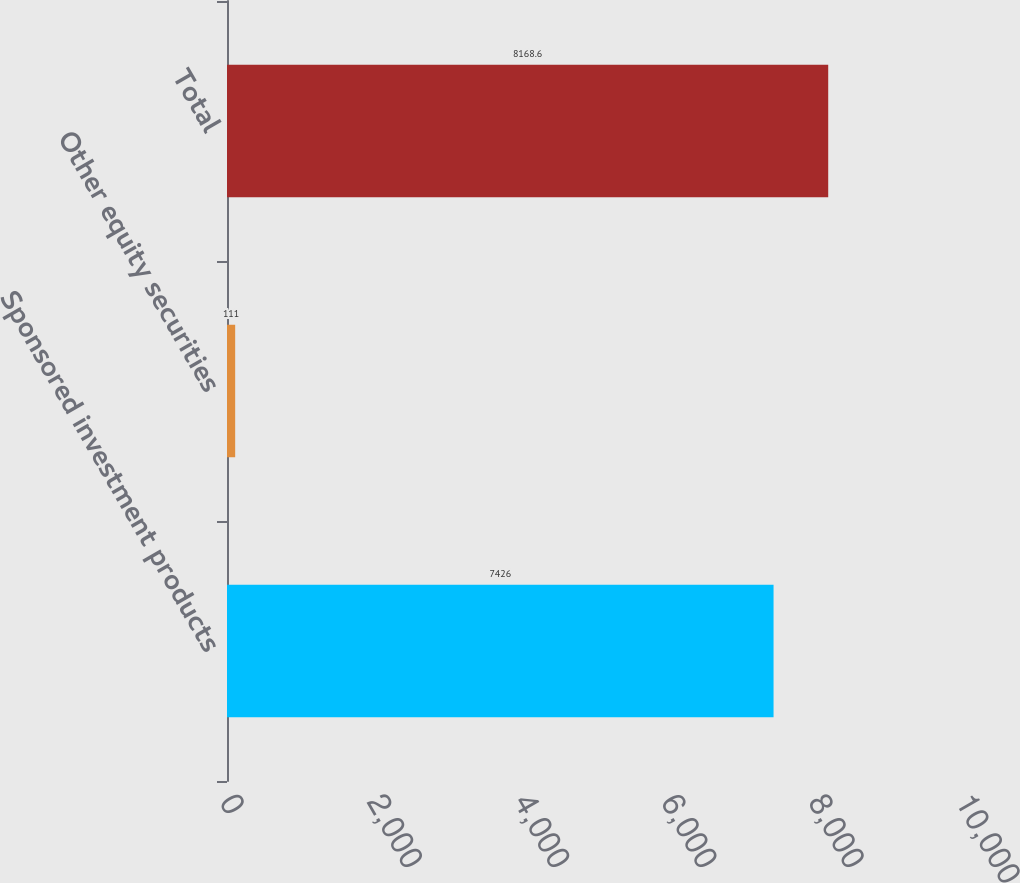Convert chart. <chart><loc_0><loc_0><loc_500><loc_500><bar_chart><fcel>Sponsored investment products<fcel>Other equity securities<fcel>Total<nl><fcel>7426<fcel>111<fcel>8168.6<nl></chart> 